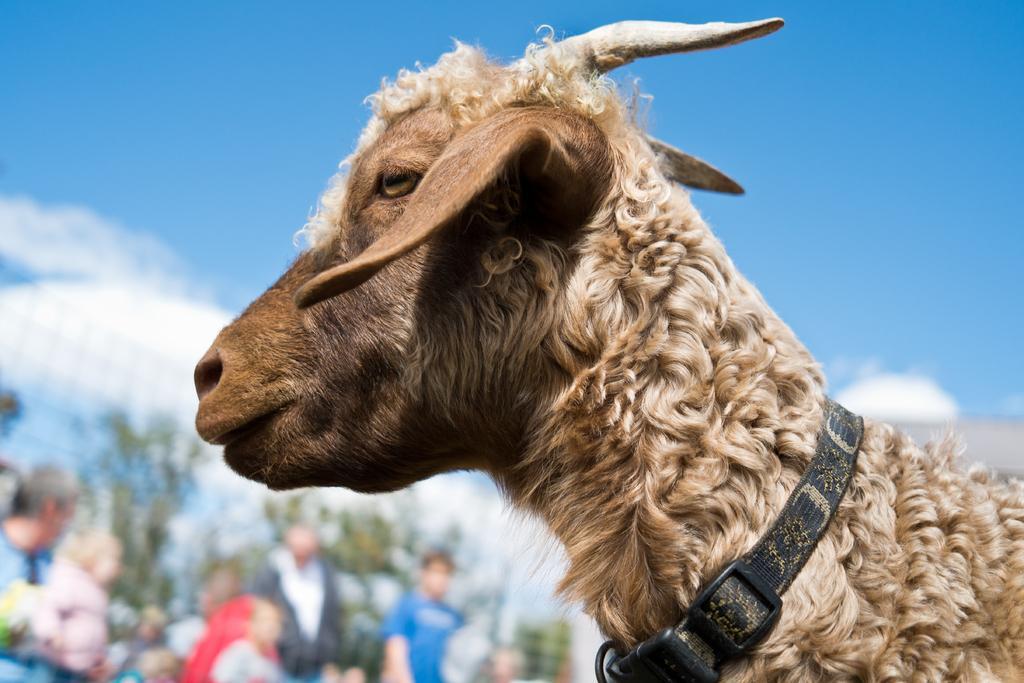How would you summarize this image in a sentence or two? In this image I can see an animal in the front. A belt is tied to its neck. The background is blurred. 